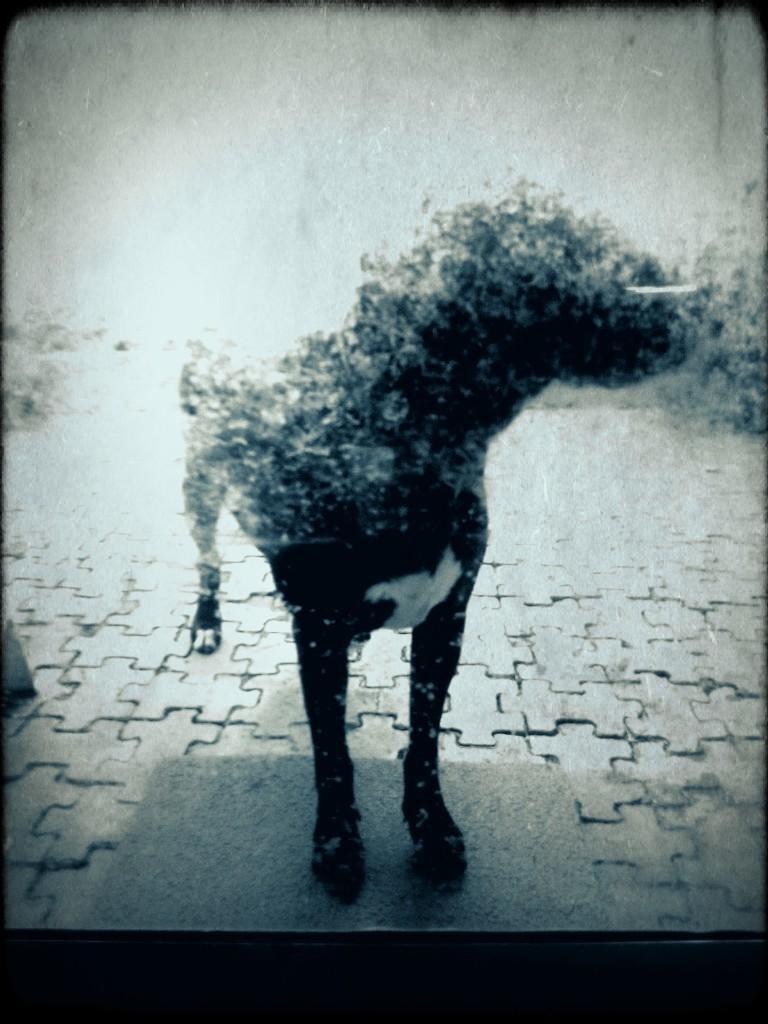Could you give a brief overview of what you see in this image? In this picture we can observe a dog which is in black and white color. We can observe a floor mat on the floor. 